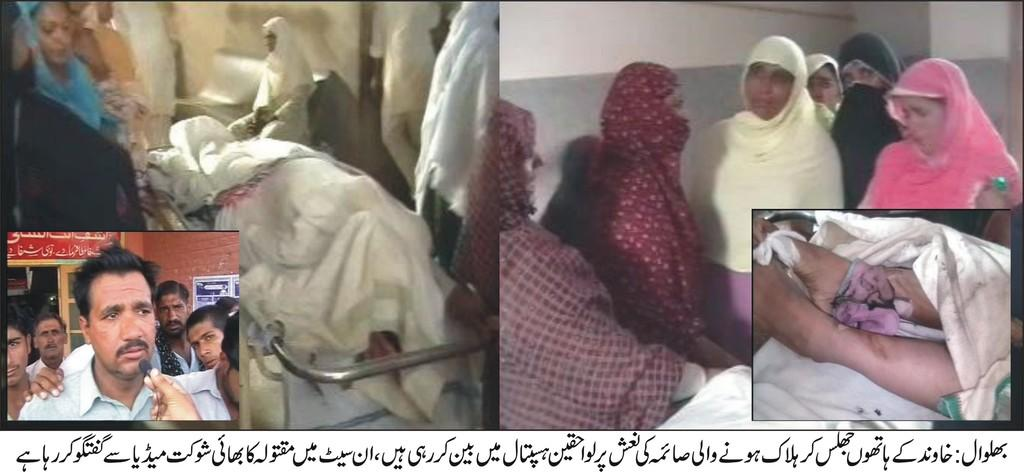What type of location is shown in the image? The image depicts a hospital view. Who can be seen in the image? There are women in the image. What are some people doing in the image? Some people are speaking to the media in the image. Can you read any text in the image? Yes, there is written text visible at the bottom of the image. How many frogs are present in the image? There are no frogs visible in the image. What does the team need to do in the image? There is no team present in the image, so it's not possible to determine what they might need to do. 